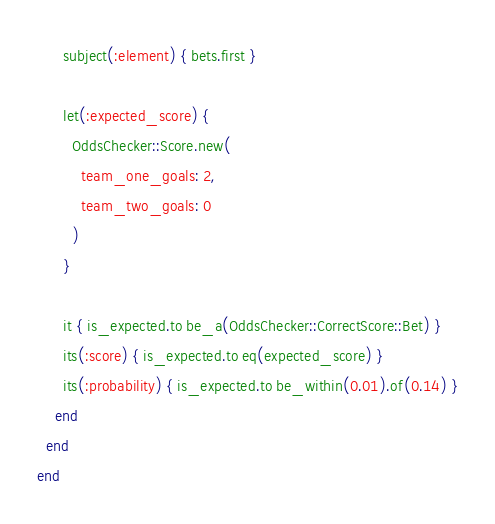Convert code to text. <code><loc_0><loc_0><loc_500><loc_500><_Ruby_>      subject(:element) { bets.first }

      let(:expected_score) {
        OddsChecker::Score.new(
          team_one_goals: 2,
          team_two_goals: 0
        )
      }

      it { is_expected.to be_a(OddsChecker::CorrectScore::Bet) }
      its(:score) { is_expected.to eq(expected_score) }
      its(:probability) { is_expected.to be_within(0.01).of(0.14) }
    end
  end
end
</code> 